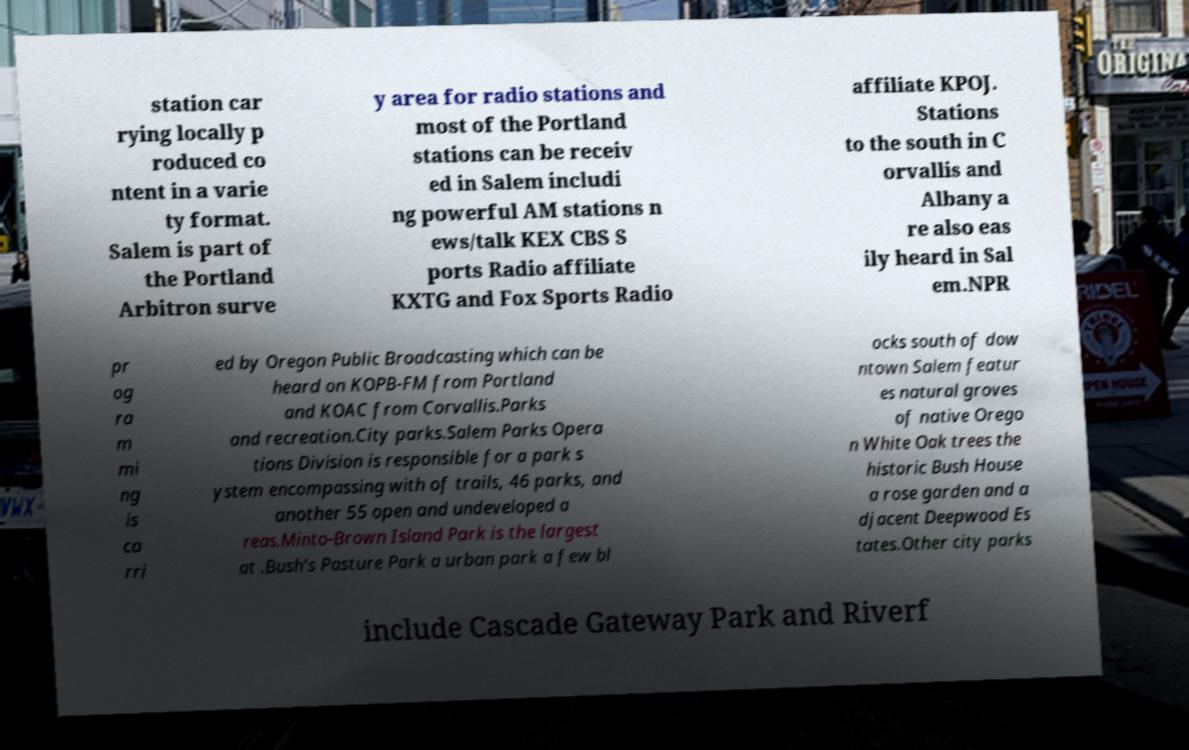Can you accurately transcribe the text from the provided image for me? station car rying locally p roduced co ntent in a varie ty format. Salem is part of the Portland Arbitron surve y area for radio stations and most of the Portland stations can be receiv ed in Salem includi ng powerful AM stations n ews/talk KEX CBS S ports Radio affiliate KXTG and Fox Sports Radio affiliate KPOJ. Stations to the south in C orvallis and Albany a re also eas ily heard in Sal em.NPR pr og ra m mi ng is ca rri ed by Oregon Public Broadcasting which can be heard on KOPB-FM from Portland and KOAC from Corvallis.Parks and recreation.City parks.Salem Parks Opera tions Division is responsible for a park s ystem encompassing with of trails, 46 parks, and another 55 open and undeveloped a reas.Minto-Brown Island Park is the largest at .Bush's Pasture Park a urban park a few bl ocks south of dow ntown Salem featur es natural groves of native Orego n White Oak trees the historic Bush House a rose garden and a djacent Deepwood Es tates.Other city parks include Cascade Gateway Park and Riverf 